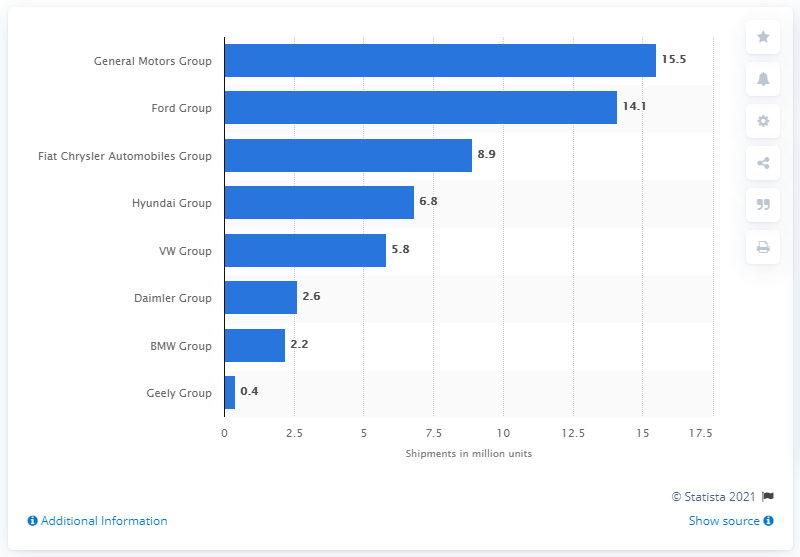Point out several critical features in this image. Ford's ADAS shipments are expected to grow to 14.1% in 2020. 